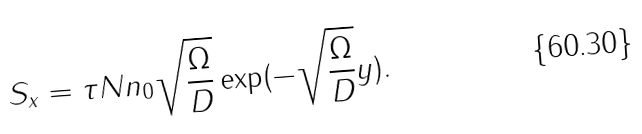<formula> <loc_0><loc_0><loc_500><loc_500>S _ { x } = \tau N n _ { 0 } \sqrt { \frac { \Omega } { D } } \exp ( - \sqrt { \frac { \Omega } { D } } y ) .</formula> 